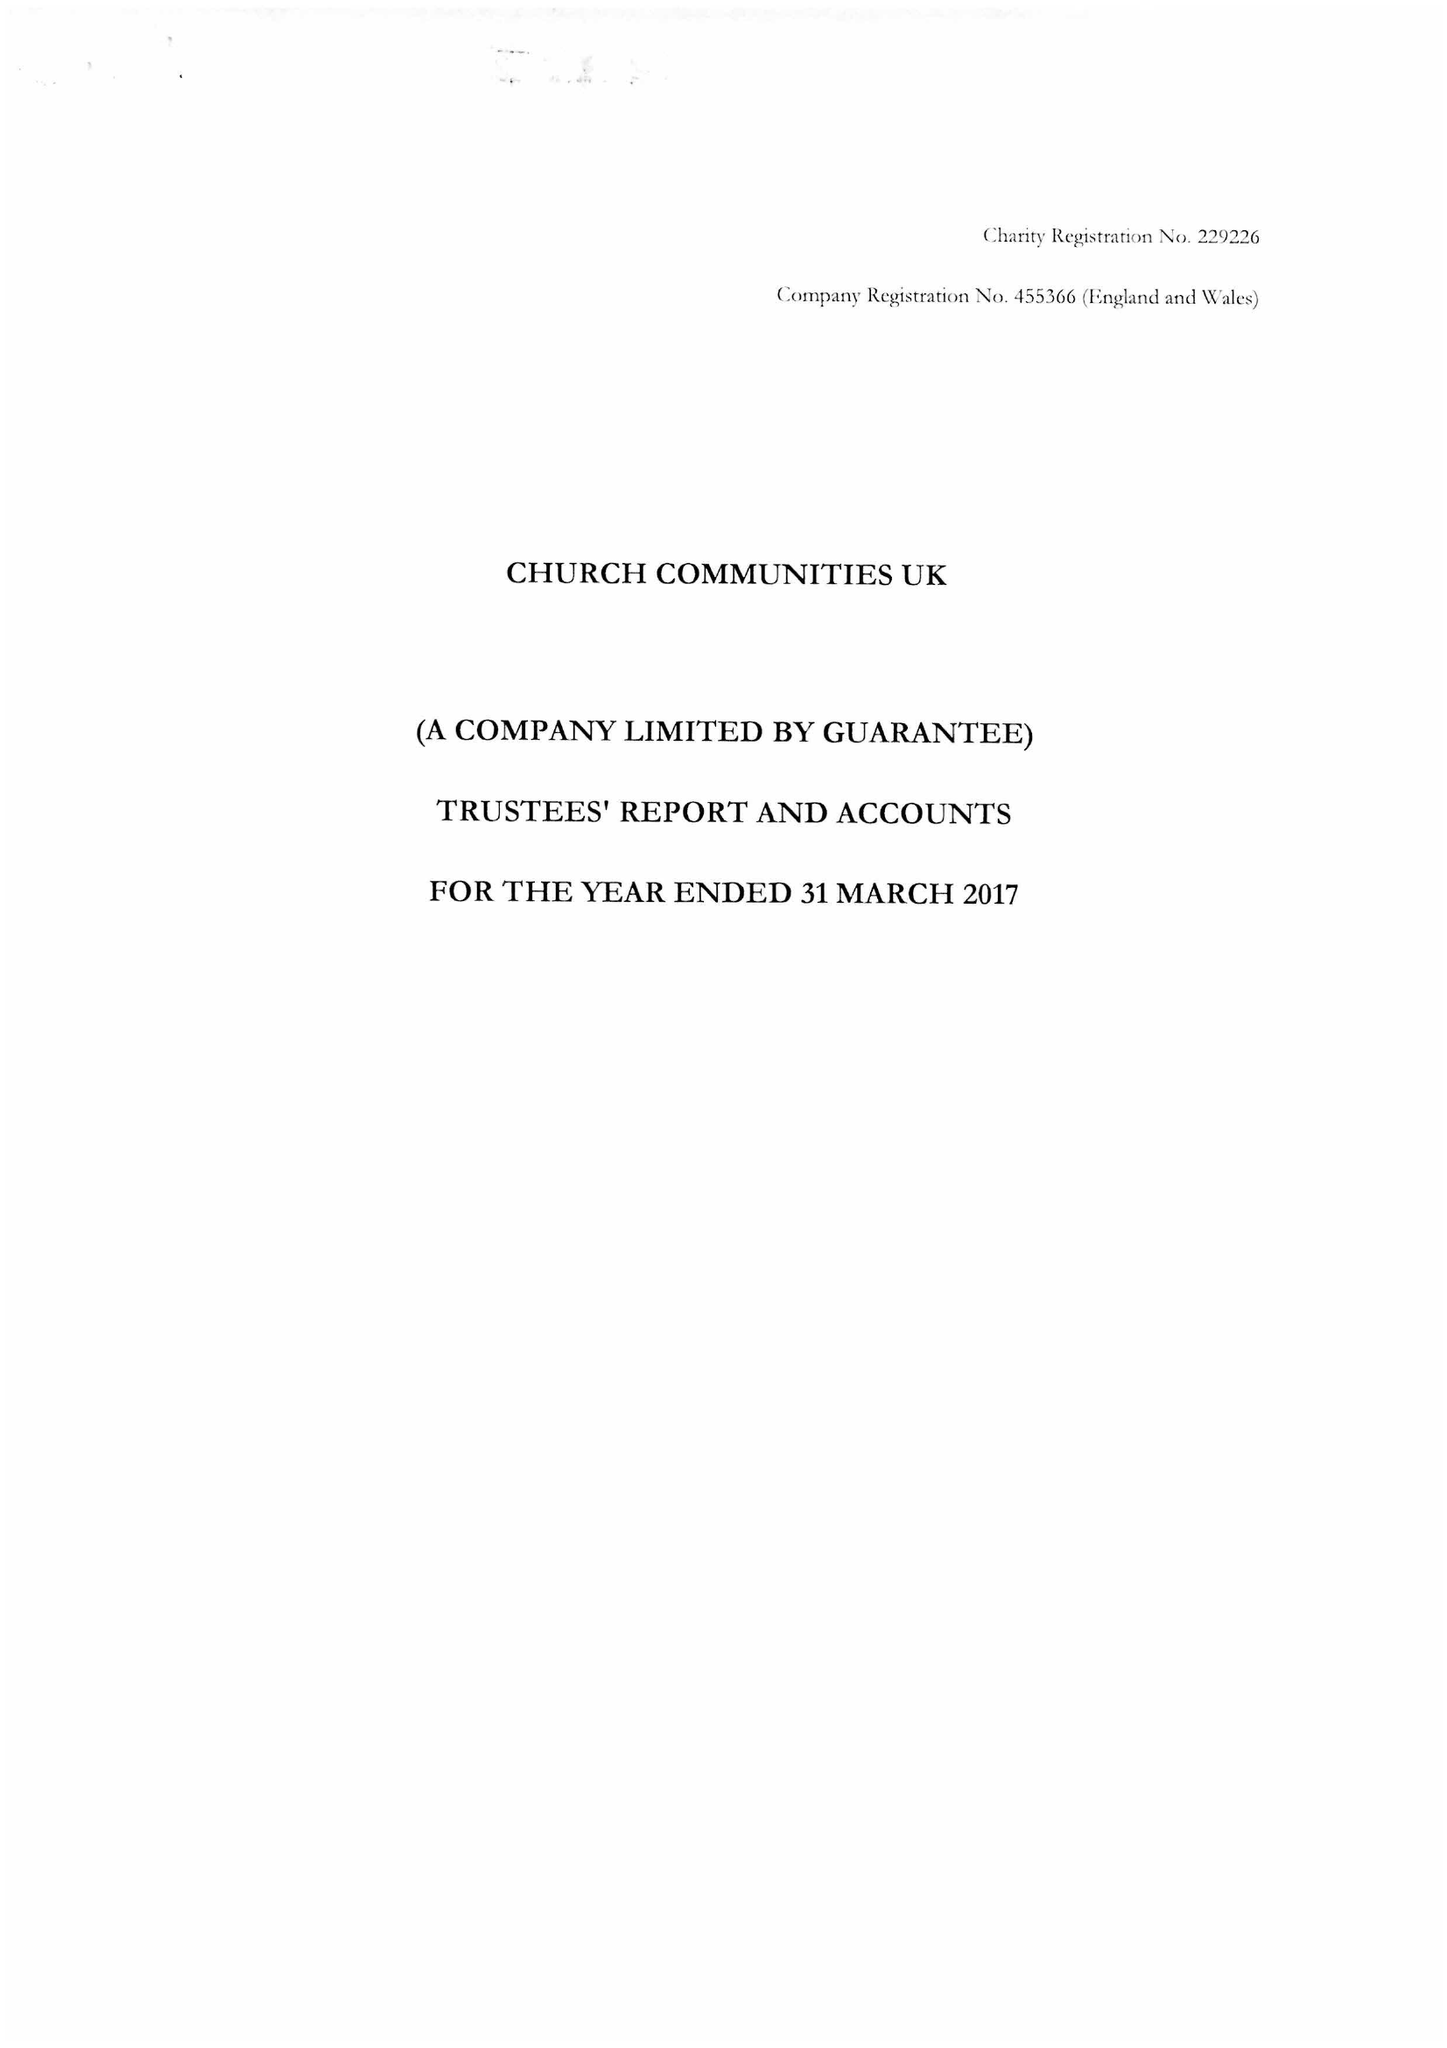What is the value for the address__post_town?
Answer the question using a single word or phrase. ROBERTSBRIDGE 